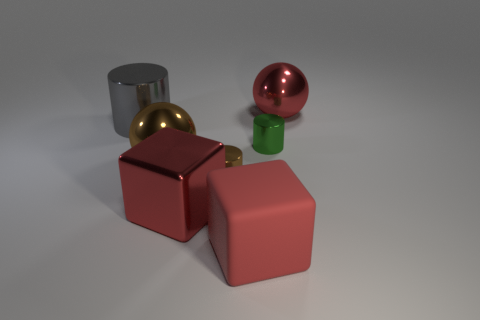The big rubber thing that is the same color as the metallic cube is what shape?
Make the answer very short. Cube. Does the red metallic thing that is to the right of the brown shiny cylinder have the same shape as the big brown object?
Give a very brief answer. Yes. Are there more large gray cylinders in front of the large red ball than brown metallic things?
Offer a very short reply. No. How many green metal cylinders are the same size as the red matte thing?
Your response must be concise. 0. What size is the metal ball that is the same color as the matte object?
Give a very brief answer. Large. What number of objects are either small gray matte cubes or metallic objects that are right of the big red metal cube?
Give a very brief answer. 3. What is the color of the metallic object that is in front of the gray cylinder and on the right side of the matte object?
Keep it short and to the point. Green. Is the size of the red rubber object the same as the brown ball?
Provide a short and direct response. Yes. The large thing to the right of the large matte block is what color?
Make the answer very short. Red. Are there any blocks that have the same color as the large rubber thing?
Your answer should be compact. Yes. 